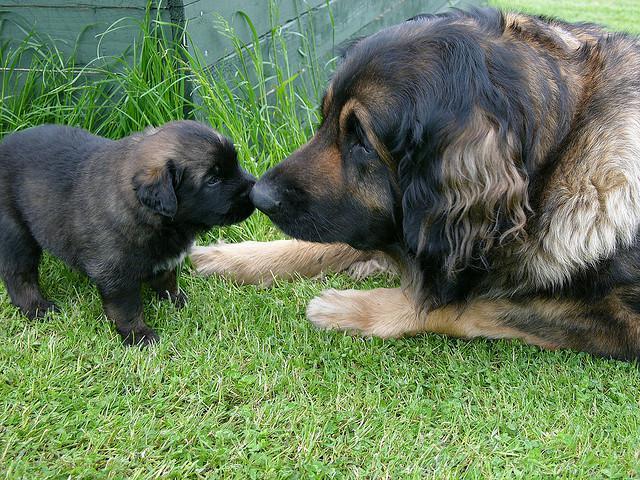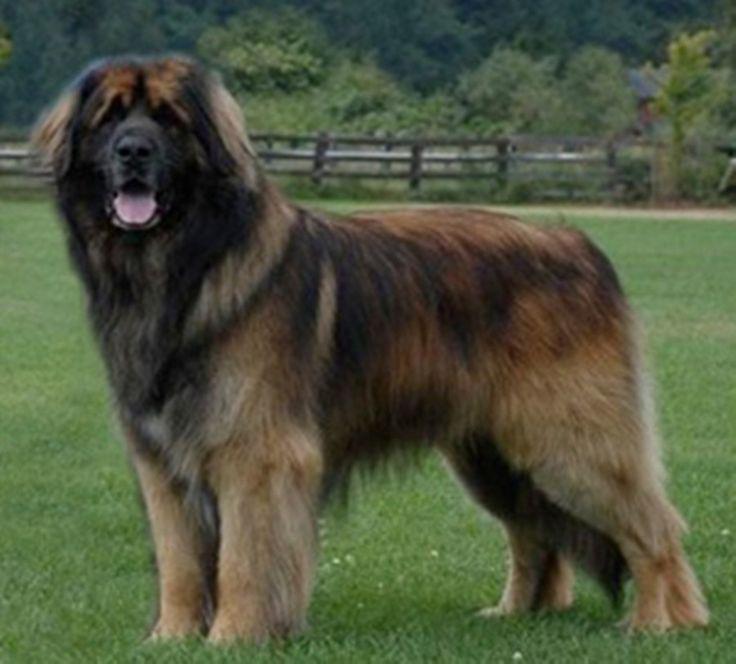The first image is the image on the left, the second image is the image on the right. Examine the images to the left and right. Is the description "One image includes a dog standing in profile, and the other image contains at least two dogs." accurate? Answer yes or no. Yes. The first image is the image on the left, the second image is the image on the right. Given the left and right images, does the statement "There are exactly two dogs in the left image." hold true? Answer yes or no. Yes. 